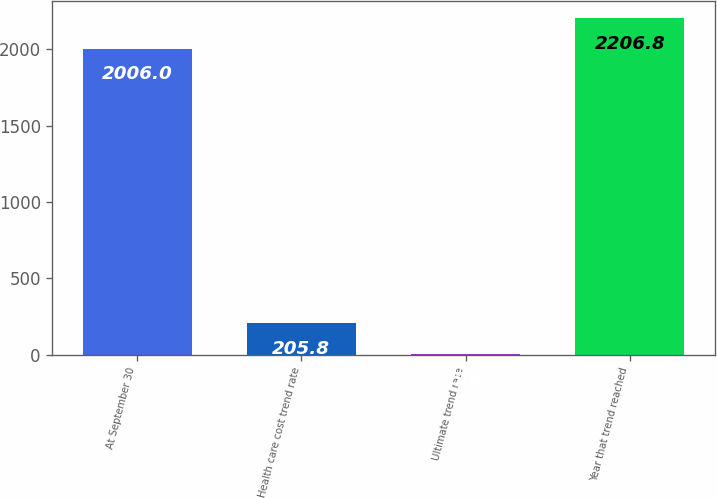Convert chart. <chart><loc_0><loc_0><loc_500><loc_500><bar_chart><fcel>At September 30<fcel>Health care cost trend rate<fcel>Ultimate trend rate<fcel>Year that trend reached<nl><fcel>2006<fcel>205.8<fcel>5<fcel>2206.8<nl></chart> 